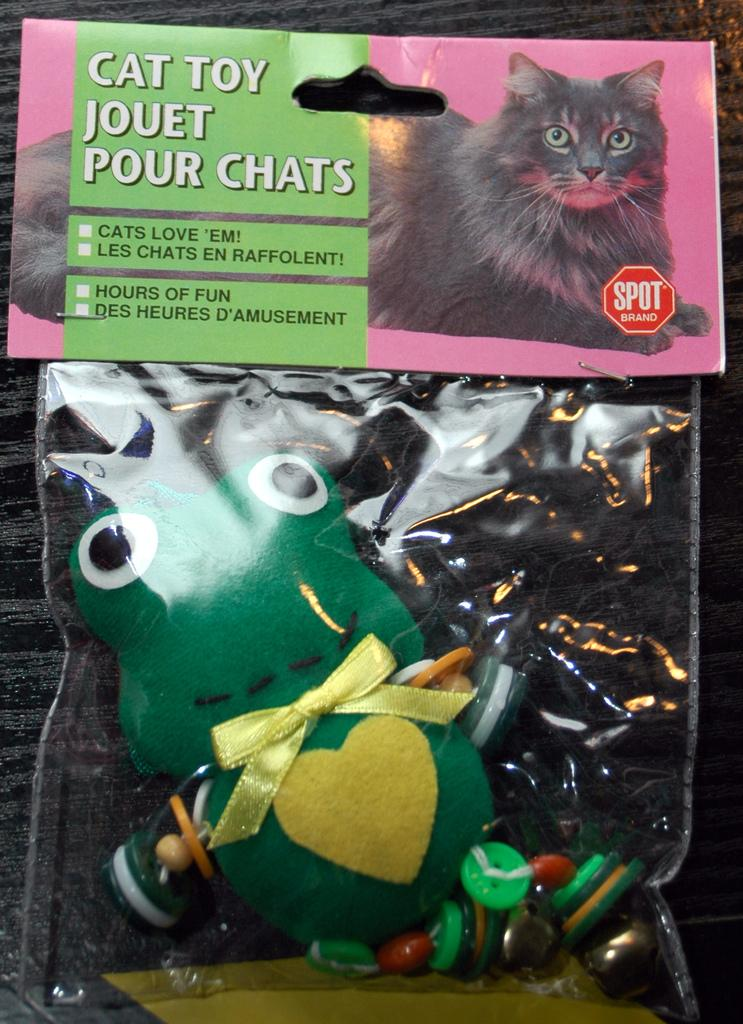What is the main subject of the image? The main subject of the image is a doll. How is the doll being protected or preserved in the image? The doll is covered in a plastic cover. Is there any additional information provided about the doll or its packaging? Yes, there is a card above the packet (assuming "packet" refers to the plastic cover). How many cars can be seen driving along the coast in the image? There are no cars or coast visible in the image; it features a doll covered in a plastic cover with a card above the packet. 